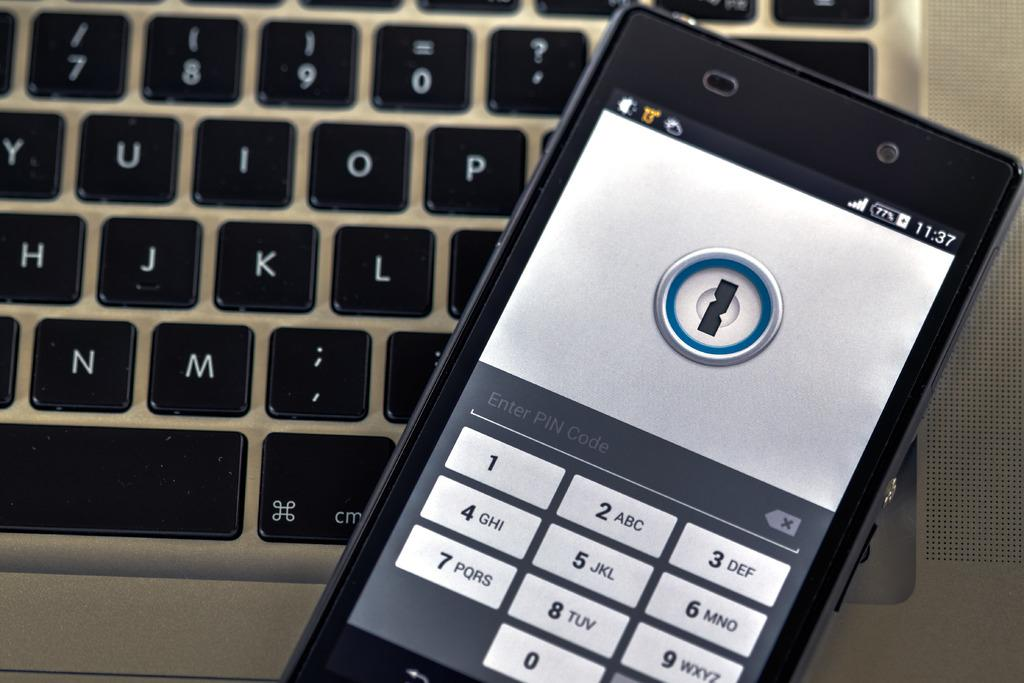<image>
Share a concise interpretation of the image provided. phone at the lock screen showing time of 11:37 and 77% battery life left laying on top of laptop keyboard 